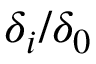Convert formula to latex. <formula><loc_0><loc_0><loc_500><loc_500>\delta _ { i } / \delta _ { 0 }</formula> 